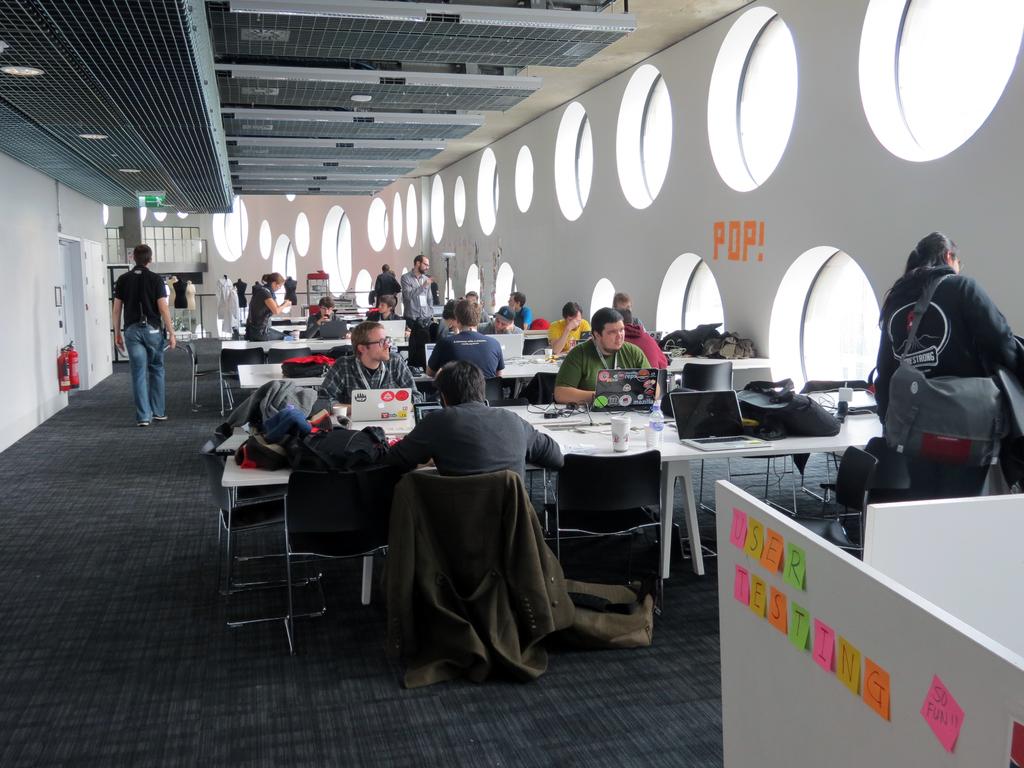What word is spelled in orange on the wall with sticky notes?
Give a very brief answer. Pop. What words are spelled out in post it notes towards the front?
Make the answer very short. User testing. 